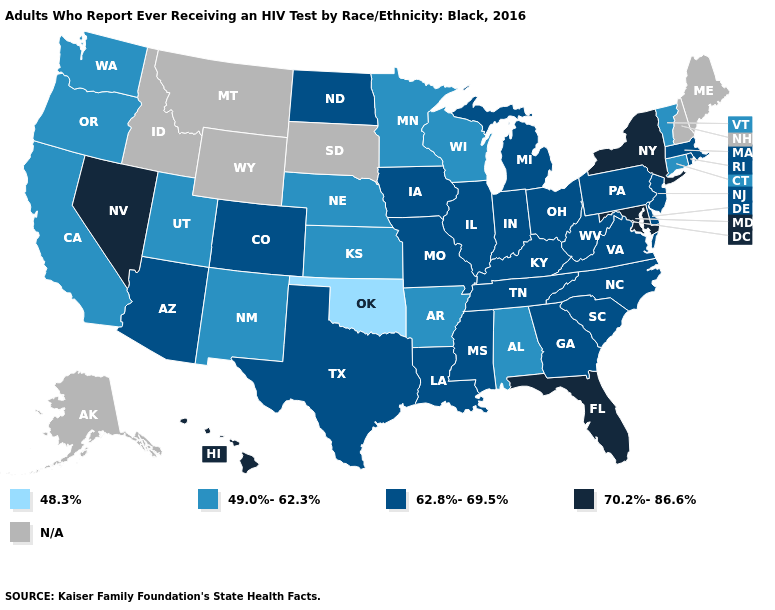Name the states that have a value in the range 62.8%-69.5%?
Give a very brief answer. Arizona, Colorado, Delaware, Georgia, Illinois, Indiana, Iowa, Kentucky, Louisiana, Massachusetts, Michigan, Mississippi, Missouri, New Jersey, North Carolina, North Dakota, Ohio, Pennsylvania, Rhode Island, South Carolina, Tennessee, Texas, Virginia, West Virginia. Name the states that have a value in the range 48.3%?
Quick response, please. Oklahoma. What is the lowest value in the USA?
Keep it brief. 48.3%. What is the highest value in the USA?
Concise answer only. 70.2%-86.6%. Name the states that have a value in the range 49.0%-62.3%?
Be succinct. Alabama, Arkansas, California, Connecticut, Kansas, Minnesota, Nebraska, New Mexico, Oregon, Utah, Vermont, Washington, Wisconsin. Name the states that have a value in the range N/A?
Quick response, please. Alaska, Idaho, Maine, Montana, New Hampshire, South Dakota, Wyoming. How many symbols are there in the legend?
Give a very brief answer. 5. Which states have the lowest value in the MidWest?
Keep it brief. Kansas, Minnesota, Nebraska, Wisconsin. What is the lowest value in the West?
Answer briefly. 49.0%-62.3%. Does the map have missing data?
Give a very brief answer. Yes. Among the states that border Connecticut , does New York have the highest value?
Quick response, please. Yes. How many symbols are there in the legend?
Be succinct. 5. What is the highest value in the South ?
Give a very brief answer. 70.2%-86.6%. Does Alabama have the lowest value in the USA?
Be succinct. No. What is the highest value in the USA?
Be succinct. 70.2%-86.6%. 